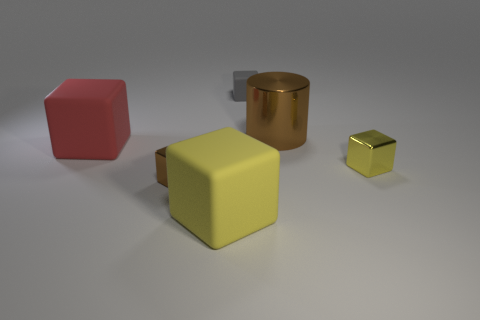What shape is the small thing that is both in front of the large brown cylinder and left of the cylinder?
Provide a short and direct response. Cube. What number of small yellow blocks are made of the same material as the cylinder?
Offer a terse response. 1. Is the number of things on the left side of the tiny yellow metal block less than the number of big purple cubes?
Give a very brief answer. No. There is a metal block that is on the left side of the big yellow object; are there any shiny things behind it?
Your answer should be compact. Yes. Are there any other things that have the same shape as the large red rubber thing?
Provide a succinct answer. Yes. Does the brown cylinder have the same size as the gray rubber thing?
Keep it short and to the point. No. The small thing in front of the tiny object right of the small object behind the large metallic cylinder is made of what material?
Give a very brief answer. Metal. Is the number of red cubes right of the yellow shiny object the same as the number of blue metal balls?
Offer a terse response. Yes. Is there anything else that has the same size as the yellow metal cube?
Ensure brevity in your answer.  Yes. What number of things are either gray cubes or yellow shiny blocks?
Your answer should be compact. 2. 